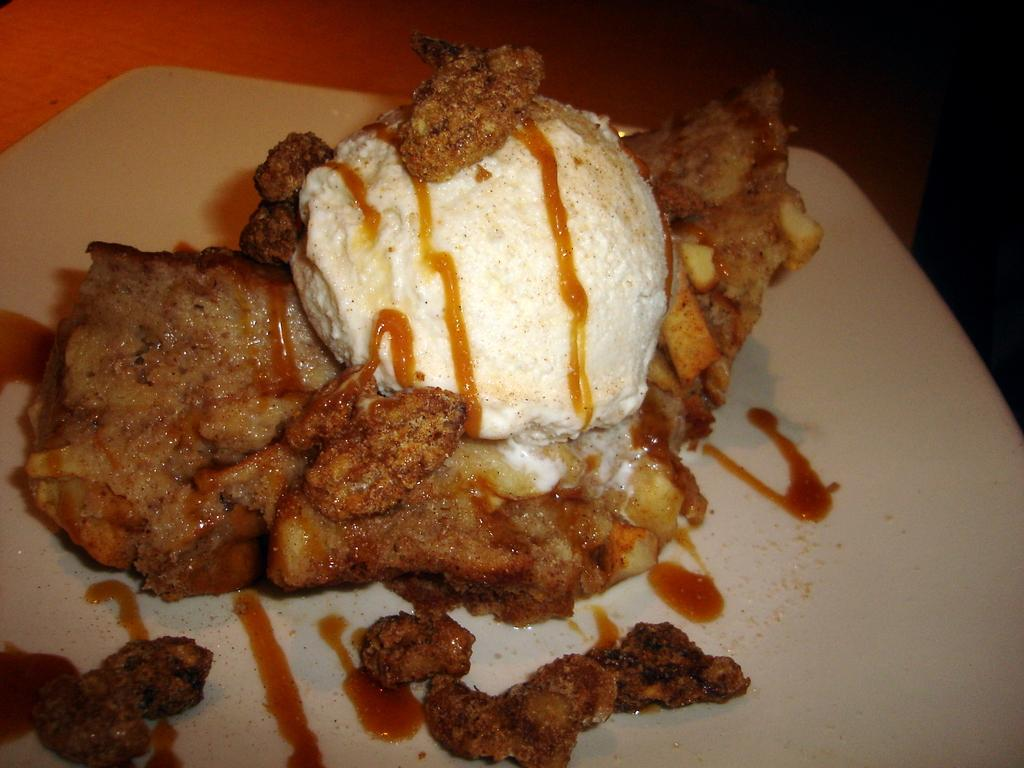What is present on the table in the image? There is food on a table in the image. Can you describe the colors of the food? The food is in white and brown colors. What level of difficulty is the food designed for in the image? The image does not provide information about the difficulty level of the food. How many times has the food been prepared in the image? The image does not provide information about the number of times the food has been prepared. 